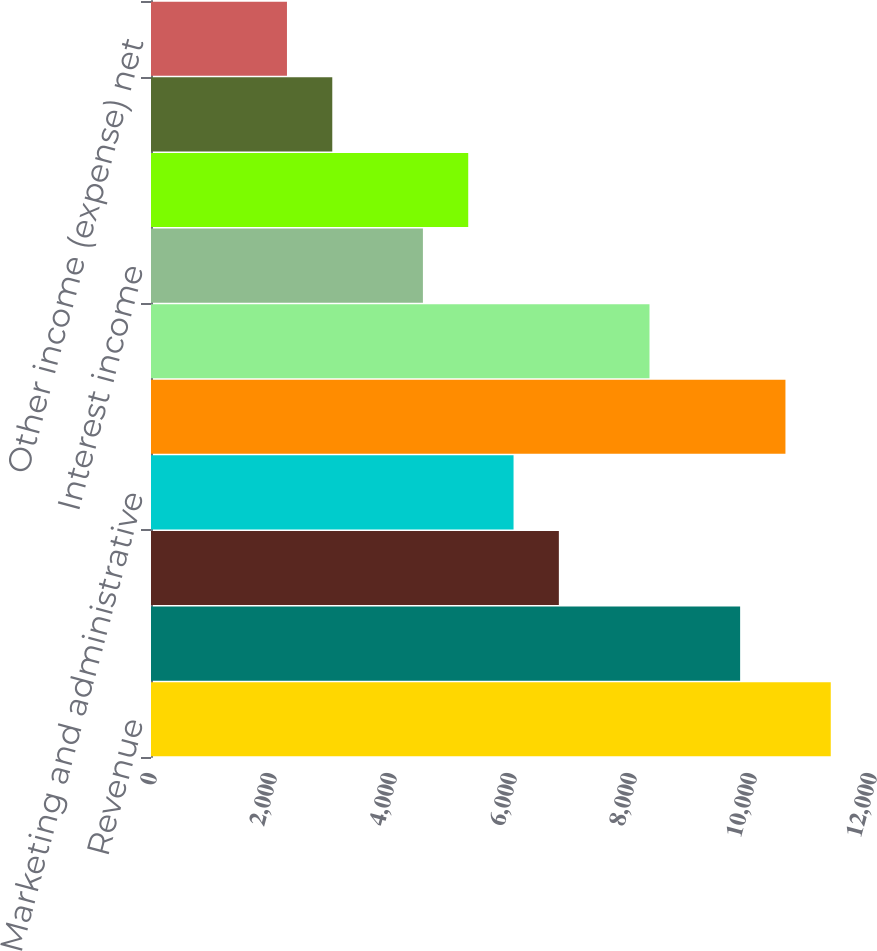<chart> <loc_0><loc_0><loc_500><loc_500><bar_chart><fcel>Revenue<fcel>Cost of revenue<fcel>Product development<fcel>Marketing and administrative<fcel>Total operating expenses<fcel>Income from operations<fcel>Interest income<fcel>Interest expense<fcel>Other net<fcel>Other income (expense) net<nl><fcel>11329.3<fcel>9818.77<fcel>6797.69<fcel>6042.42<fcel>10574<fcel>8308.23<fcel>4531.88<fcel>5287.15<fcel>3021.34<fcel>2266.07<nl></chart> 